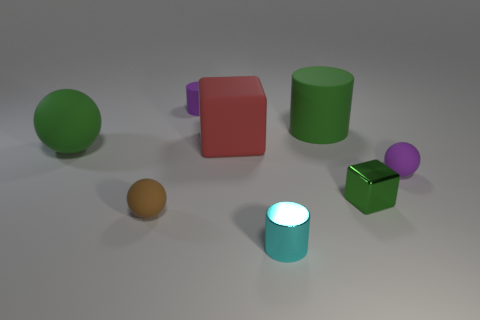How many tiny things are the same color as the big sphere?
Provide a short and direct response. 1. Do the thing to the right of the small green cube and the small rubber cylinder have the same color?
Offer a terse response. Yes. Are there any other things that are the same color as the small shiny block?
Offer a terse response. Yes. Is the large cylinder the same color as the tiny cube?
Make the answer very short. Yes. What shape is the shiny thing that is the same color as the big rubber cylinder?
Give a very brief answer. Cube. What size is the green ball that is the same material as the big cylinder?
Provide a short and direct response. Large. Do the cyan metal object and the green matte sphere have the same size?
Make the answer very short. No. Are any metallic spheres visible?
Make the answer very short. No. What size is the metal object that is the same color as the large matte sphere?
Provide a short and direct response. Small. How big is the matte thing that is left of the tiny brown ball that is to the left of the tiny cylinder that is in front of the large red cube?
Make the answer very short. Large. 